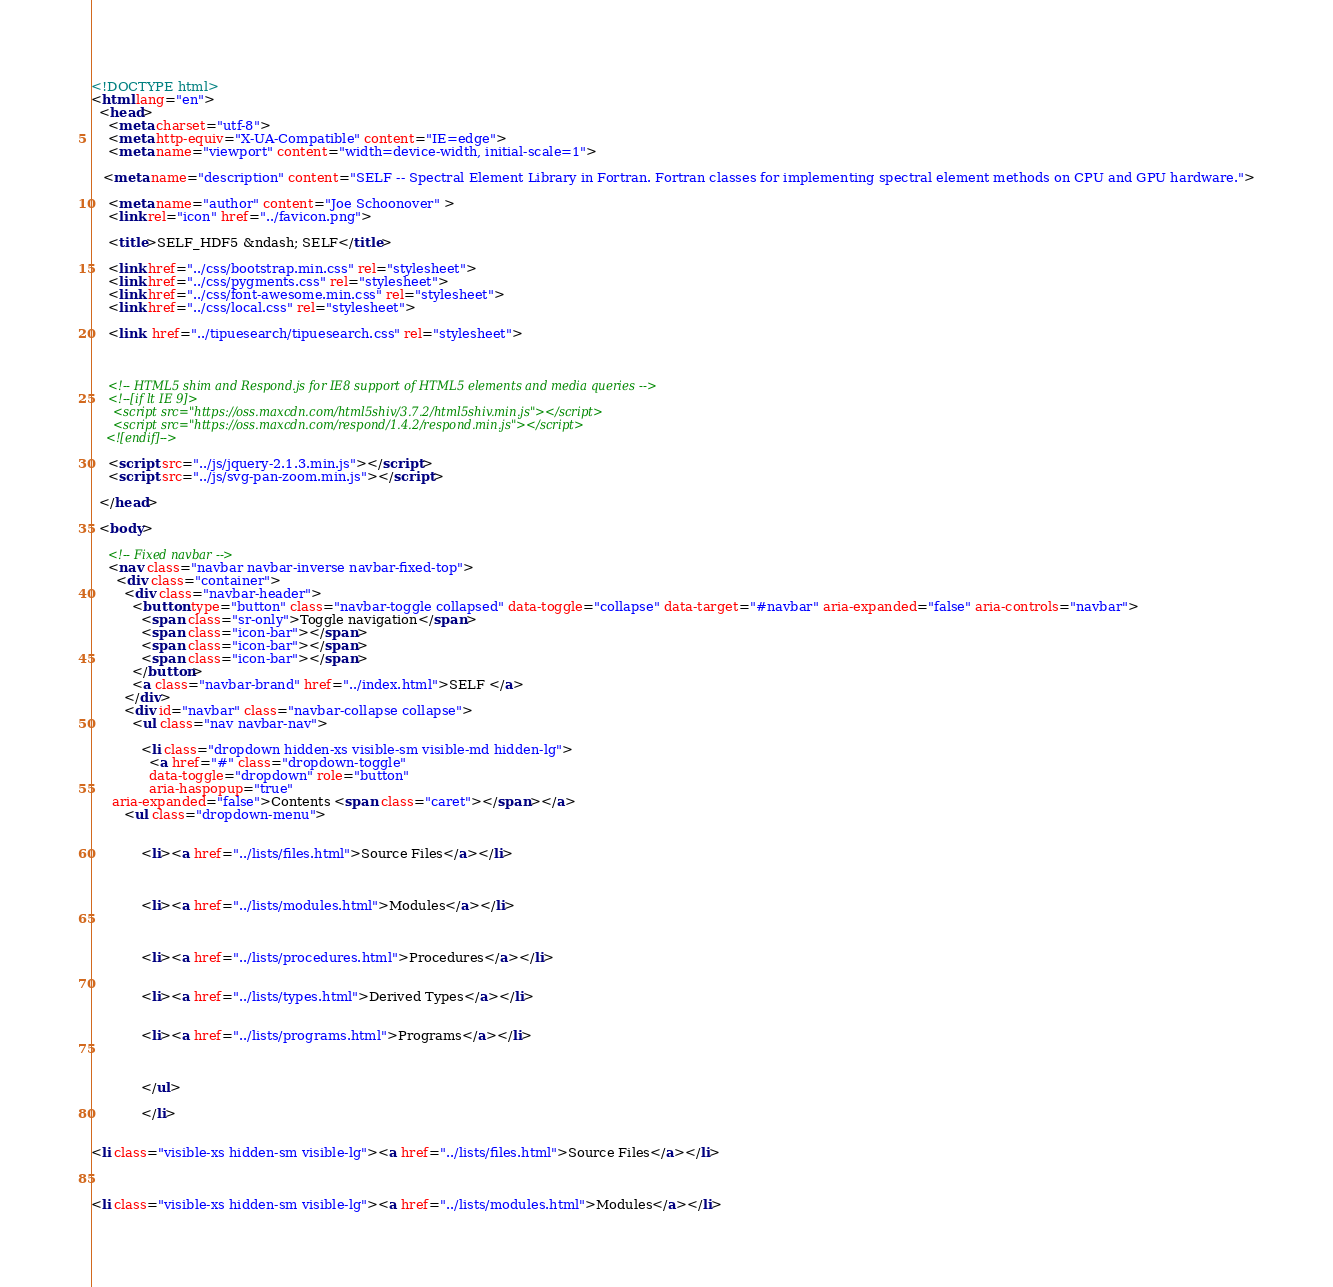<code> <loc_0><loc_0><loc_500><loc_500><_HTML_><!DOCTYPE html>
<html lang="en">
  <head>
    <meta charset="utf-8">
    <meta http-equiv="X-UA-Compatible" content="IE=edge">
    <meta name="viewport" content="width=device-width, initial-scale=1">
   
   <meta name="description" content="SELF -- Spectral Element Library in Fortran. Fortran classes for implementing spectral element methods on CPU and GPU hardware.">
    
    <meta name="author" content="Joe Schoonover" >
    <link rel="icon" href="../favicon.png">

    <title>SELF_HDF5 &ndash; SELF</title>

    <link href="../css/bootstrap.min.css" rel="stylesheet">
    <link href="../css/pygments.css" rel="stylesheet">
    <link href="../css/font-awesome.min.css" rel="stylesheet">
    <link href="../css/local.css" rel="stylesheet">
    
    <link  href="../tipuesearch/tipuesearch.css" rel="stylesheet">
    
    

    <!-- HTML5 shim and Respond.js for IE8 support of HTML5 elements and media queries -->
    <!--[if lt IE 9]>
      <script src="https://oss.maxcdn.com/html5shiv/3.7.2/html5shiv.min.js"></script>
      <script src="https://oss.maxcdn.com/respond/1.4.2/respond.min.js"></script>
    <![endif]-->
    
    <script src="../js/jquery-2.1.3.min.js"></script>
    <script src="../js/svg-pan-zoom.min.js"></script>

  </head>

  <body>

    <!-- Fixed navbar -->
    <nav class="navbar navbar-inverse navbar-fixed-top">
      <div class="container">
        <div class="navbar-header">
          <button type="button" class="navbar-toggle collapsed" data-toggle="collapse" data-target="#navbar" aria-expanded="false" aria-controls="navbar">
            <span class="sr-only">Toggle navigation</span>
            <span class="icon-bar"></span>
            <span class="icon-bar"></span>
            <span class="icon-bar"></span>
          </button>
          <a class="navbar-brand" href="../index.html">SELF </a>
        </div>
        <div id="navbar" class="navbar-collapse collapse">
          <ul class="nav navbar-nav">
        
            <li class="dropdown hidden-xs visible-sm visible-md hidden-lg">
              <a href="#" class="dropdown-toggle"
              data-toggle="dropdown" role="button"
              aria-haspopup="true"
     aria-expanded="false">Contents <span class="caret"></span></a>
        <ul class="dropdown-menu">
          
              
            <li><a href="../lists/files.html">Source Files</a></li>
        
        
        
            <li><a href="../lists/modules.html">Modules</a></li>
        
            
                                
            <li><a href="../lists/procedures.html">Procedures</a></li>
        
               
            <li><a href="../lists/types.html">Derived Types</a></li>
        
        
            <li><a href="../lists/programs.html">Programs</a></li>
               
        
        
            </ul>
        
            </li>


<li class="visible-xs hidden-sm visible-lg"><a href="../lists/files.html">Source Files</a></li>



<li class="visible-xs hidden-sm visible-lg"><a href="../lists/modules.html">Modules</a></li>


</code> 